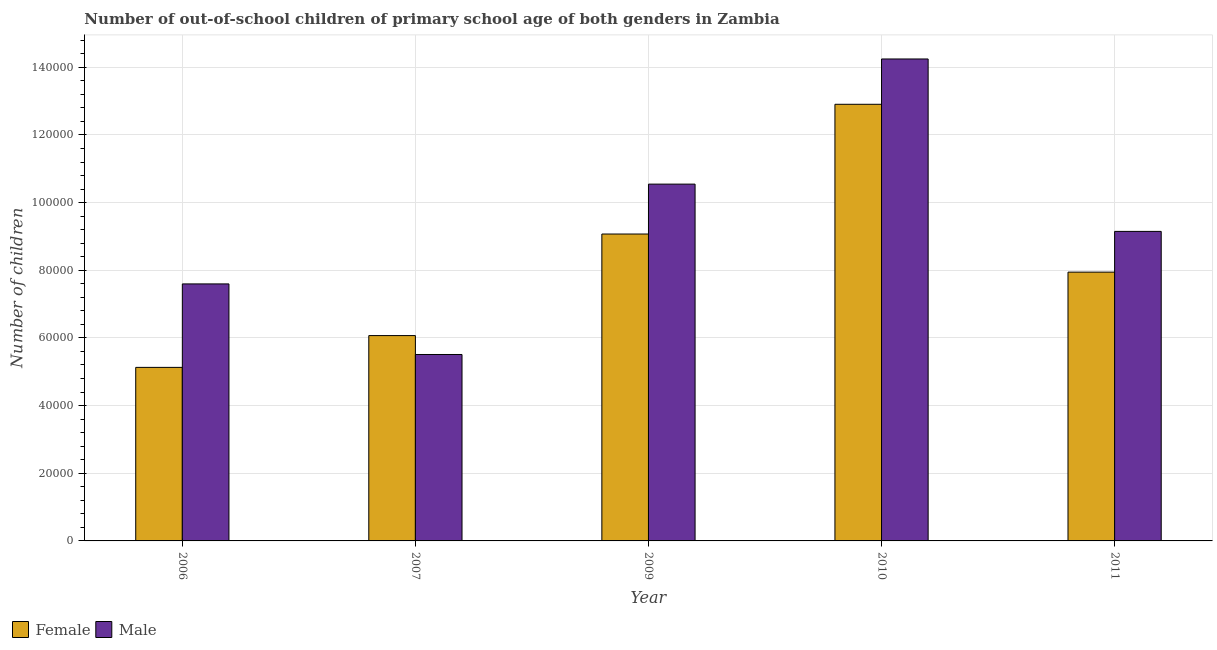How many groups of bars are there?
Offer a very short reply. 5. Are the number of bars on each tick of the X-axis equal?
Your answer should be very brief. Yes. How many bars are there on the 1st tick from the left?
Give a very brief answer. 2. What is the number of female out-of-school students in 2009?
Your response must be concise. 9.07e+04. Across all years, what is the maximum number of female out-of-school students?
Offer a terse response. 1.29e+05. Across all years, what is the minimum number of male out-of-school students?
Provide a short and direct response. 5.51e+04. What is the total number of male out-of-school students in the graph?
Provide a succinct answer. 4.70e+05. What is the difference between the number of male out-of-school students in 2010 and that in 2011?
Ensure brevity in your answer.  5.10e+04. What is the difference between the number of female out-of-school students in 2007 and the number of male out-of-school students in 2009?
Your answer should be compact. -3.00e+04. What is the average number of female out-of-school students per year?
Make the answer very short. 8.22e+04. What is the ratio of the number of male out-of-school students in 2006 to that in 2009?
Ensure brevity in your answer.  0.72. Is the number of male out-of-school students in 2009 less than that in 2010?
Make the answer very short. Yes. Is the difference between the number of female out-of-school students in 2006 and 2007 greater than the difference between the number of male out-of-school students in 2006 and 2007?
Offer a very short reply. No. What is the difference between the highest and the second highest number of male out-of-school students?
Keep it short and to the point. 3.70e+04. What is the difference between the highest and the lowest number of female out-of-school students?
Make the answer very short. 7.78e+04. What does the 1st bar from the right in 2007 represents?
Provide a succinct answer. Male. How many bars are there?
Offer a very short reply. 10. Are all the bars in the graph horizontal?
Make the answer very short. No. What is the difference between two consecutive major ticks on the Y-axis?
Provide a short and direct response. 2.00e+04. Are the values on the major ticks of Y-axis written in scientific E-notation?
Provide a short and direct response. No. Does the graph contain any zero values?
Provide a short and direct response. No. Where does the legend appear in the graph?
Keep it short and to the point. Bottom left. What is the title of the graph?
Make the answer very short. Number of out-of-school children of primary school age of both genders in Zambia. Does "Study and work" appear as one of the legend labels in the graph?
Make the answer very short. No. What is the label or title of the Y-axis?
Your answer should be compact. Number of children. What is the Number of children of Female in 2006?
Ensure brevity in your answer.  5.13e+04. What is the Number of children of Male in 2006?
Keep it short and to the point. 7.60e+04. What is the Number of children in Female in 2007?
Give a very brief answer. 6.07e+04. What is the Number of children of Male in 2007?
Your answer should be very brief. 5.51e+04. What is the Number of children in Female in 2009?
Keep it short and to the point. 9.07e+04. What is the Number of children of Male in 2009?
Provide a short and direct response. 1.05e+05. What is the Number of children of Female in 2010?
Give a very brief answer. 1.29e+05. What is the Number of children of Male in 2010?
Keep it short and to the point. 1.42e+05. What is the Number of children of Female in 2011?
Ensure brevity in your answer.  7.95e+04. What is the Number of children in Male in 2011?
Offer a terse response. 9.15e+04. Across all years, what is the maximum Number of children of Female?
Your answer should be very brief. 1.29e+05. Across all years, what is the maximum Number of children in Male?
Give a very brief answer. 1.42e+05. Across all years, what is the minimum Number of children of Female?
Keep it short and to the point. 5.13e+04. Across all years, what is the minimum Number of children in Male?
Give a very brief answer. 5.51e+04. What is the total Number of children in Female in the graph?
Provide a succinct answer. 4.11e+05. What is the total Number of children in Male in the graph?
Make the answer very short. 4.70e+05. What is the difference between the Number of children in Female in 2006 and that in 2007?
Your answer should be very brief. -9399. What is the difference between the Number of children of Male in 2006 and that in 2007?
Make the answer very short. 2.09e+04. What is the difference between the Number of children in Female in 2006 and that in 2009?
Make the answer very short. -3.94e+04. What is the difference between the Number of children of Male in 2006 and that in 2009?
Your answer should be compact. -2.95e+04. What is the difference between the Number of children of Female in 2006 and that in 2010?
Offer a very short reply. -7.78e+04. What is the difference between the Number of children of Male in 2006 and that in 2010?
Keep it short and to the point. -6.65e+04. What is the difference between the Number of children in Female in 2006 and that in 2011?
Give a very brief answer. -2.82e+04. What is the difference between the Number of children in Male in 2006 and that in 2011?
Provide a succinct answer. -1.55e+04. What is the difference between the Number of children of Female in 2007 and that in 2009?
Give a very brief answer. -3.00e+04. What is the difference between the Number of children of Male in 2007 and that in 2009?
Your answer should be very brief. -5.04e+04. What is the difference between the Number of children of Female in 2007 and that in 2010?
Give a very brief answer. -6.84e+04. What is the difference between the Number of children in Male in 2007 and that in 2010?
Your answer should be compact. -8.74e+04. What is the difference between the Number of children in Female in 2007 and that in 2011?
Make the answer very short. -1.88e+04. What is the difference between the Number of children of Male in 2007 and that in 2011?
Give a very brief answer. -3.64e+04. What is the difference between the Number of children in Female in 2009 and that in 2010?
Your response must be concise. -3.83e+04. What is the difference between the Number of children of Male in 2009 and that in 2010?
Your answer should be compact. -3.70e+04. What is the difference between the Number of children of Female in 2009 and that in 2011?
Your response must be concise. 1.13e+04. What is the difference between the Number of children in Male in 2009 and that in 2011?
Provide a short and direct response. 1.40e+04. What is the difference between the Number of children in Female in 2010 and that in 2011?
Make the answer very short. 4.96e+04. What is the difference between the Number of children of Male in 2010 and that in 2011?
Your answer should be very brief. 5.10e+04. What is the difference between the Number of children in Female in 2006 and the Number of children in Male in 2007?
Keep it short and to the point. -3812. What is the difference between the Number of children of Female in 2006 and the Number of children of Male in 2009?
Keep it short and to the point. -5.42e+04. What is the difference between the Number of children of Female in 2006 and the Number of children of Male in 2010?
Your answer should be compact. -9.12e+04. What is the difference between the Number of children in Female in 2006 and the Number of children in Male in 2011?
Your answer should be very brief. -4.02e+04. What is the difference between the Number of children in Female in 2007 and the Number of children in Male in 2009?
Make the answer very short. -4.48e+04. What is the difference between the Number of children in Female in 2007 and the Number of children in Male in 2010?
Provide a succinct answer. -8.18e+04. What is the difference between the Number of children in Female in 2007 and the Number of children in Male in 2011?
Ensure brevity in your answer.  -3.08e+04. What is the difference between the Number of children of Female in 2009 and the Number of children of Male in 2010?
Offer a terse response. -5.17e+04. What is the difference between the Number of children in Female in 2009 and the Number of children in Male in 2011?
Offer a very short reply. -776. What is the difference between the Number of children of Female in 2010 and the Number of children of Male in 2011?
Your response must be concise. 3.76e+04. What is the average Number of children of Female per year?
Offer a very short reply. 8.22e+04. What is the average Number of children of Male per year?
Provide a short and direct response. 9.41e+04. In the year 2006, what is the difference between the Number of children of Female and Number of children of Male?
Make the answer very short. -2.47e+04. In the year 2007, what is the difference between the Number of children of Female and Number of children of Male?
Your answer should be very brief. 5587. In the year 2009, what is the difference between the Number of children of Female and Number of children of Male?
Your answer should be compact. -1.48e+04. In the year 2010, what is the difference between the Number of children of Female and Number of children of Male?
Provide a short and direct response. -1.34e+04. In the year 2011, what is the difference between the Number of children of Female and Number of children of Male?
Make the answer very short. -1.20e+04. What is the ratio of the Number of children in Female in 2006 to that in 2007?
Make the answer very short. 0.85. What is the ratio of the Number of children in Male in 2006 to that in 2007?
Keep it short and to the point. 1.38. What is the ratio of the Number of children in Female in 2006 to that in 2009?
Offer a very short reply. 0.57. What is the ratio of the Number of children of Male in 2006 to that in 2009?
Your answer should be very brief. 0.72. What is the ratio of the Number of children of Female in 2006 to that in 2010?
Provide a succinct answer. 0.4. What is the ratio of the Number of children in Male in 2006 to that in 2010?
Offer a terse response. 0.53. What is the ratio of the Number of children of Female in 2006 to that in 2011?
Keep it short and to the point. 0.65. What is the ratio of the Number of children of Male in 2006 to that in 2011?
Your answer should be compact. 0.83. What is the ratio of the Number of children of Female in 2007 to that in 2009?
Keep it short and to the point. 0.67. What is the ratio of the Number of children in Male in 2007 to that in 2009?
Provide a succinct answer. 0.52. What is the ratio of the Number of children of Female in 2007 to that in 2010?
Give a very brief answer. 0.47. What is the ratio of the Number of children of Male in 2007 to that in 2010?
Keep it short and to the point. 0.39. What is the ratio of the Number of children in Female in 2007 to that in 2011?
Offer a very short reply. 0.76. What is the ratio of the Number of children in Male in 2007 to that in 2011?
Your response must be concise. 0.6. What is the ratio of the Number of children in Female in 2009 to that in 2010?
Your response must be concise. 0.7. What is the ratio of the Number of children of Male in 2009 to that in 2010?
Make the answer very short. 0.74. What is the ratio of the Number of children in Female in 2009 to that in 2011?
Your response must be concise. 1.14. What is the ratio of the Number of children of Male in 2009 to that in 2011?
Give a very brief answer. 1.15. What is the ratio of the Number of children of Female in 2010 to that in 2011?
Keep it short and to the point. 1.62. What is the ratio of the Number of children in Male in 2010 to that in 2011?
Offer a terse response. 1.56. What is the difference between the highest and the second highest Number of children in Female?
Make the answer very short. 3.83e+04. What is the difference between the highest and the second highest Number of children of Male?
Ensure brevity in your answer.  3.70e+04. What is the difference between the highest and the lowest Number of children of Female?
Ensure brevity in your answer.  7.78e+04. What is the difference between the highest and the lowest Number of children in Male?
Provide a short and direct response. 8.74e+04. 